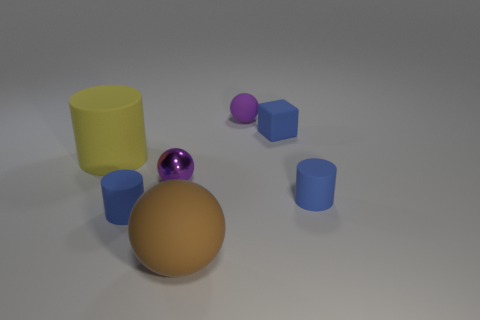What number of large yellow things are behind the blue rubber cylinder that is on the left side of the blue thing behind the big rubber cylinder?
Provide a short and direct response. 1. Is the shape of the big yellow matte object the same as the purple matte thing right of the large brown matte ball?
Your response must be concise. No. There is a ball that is to the right of the small purple shiny object and in front of the large yellow rubber cylinder; what is its color?
Make the answer very short. Brown. There is a small purple thing that is behind the yellow matte cylinder that is behind the rubber cylinder that is right of the purple matte sphere; what is it made of?
Keep it short and to the point. Rubber. There is a purple rubber thing that is the same shape as the big brown rubber object; what size is it?
Offer a very short reply. Small. Does the small rubber sphere have the same color as the small metallic thing?
Your answer should be compact. Yes. What number of other things are there of the same material as the tiny blue block
Offer a terse response. 5. Are there an equal number of purple objects in front of the large rubber cylinder and tiny purple shiny things?
Keep it short and to the point. Yes. There is a blue rubber cylinder that is to the left of the brown matte object; is it the same size as the tiny blue cube?
Provide a short and direct response. Yes. What number of tiny purple balls are behind the yellow rubber cylinder?
Offer a terse response. 1. 